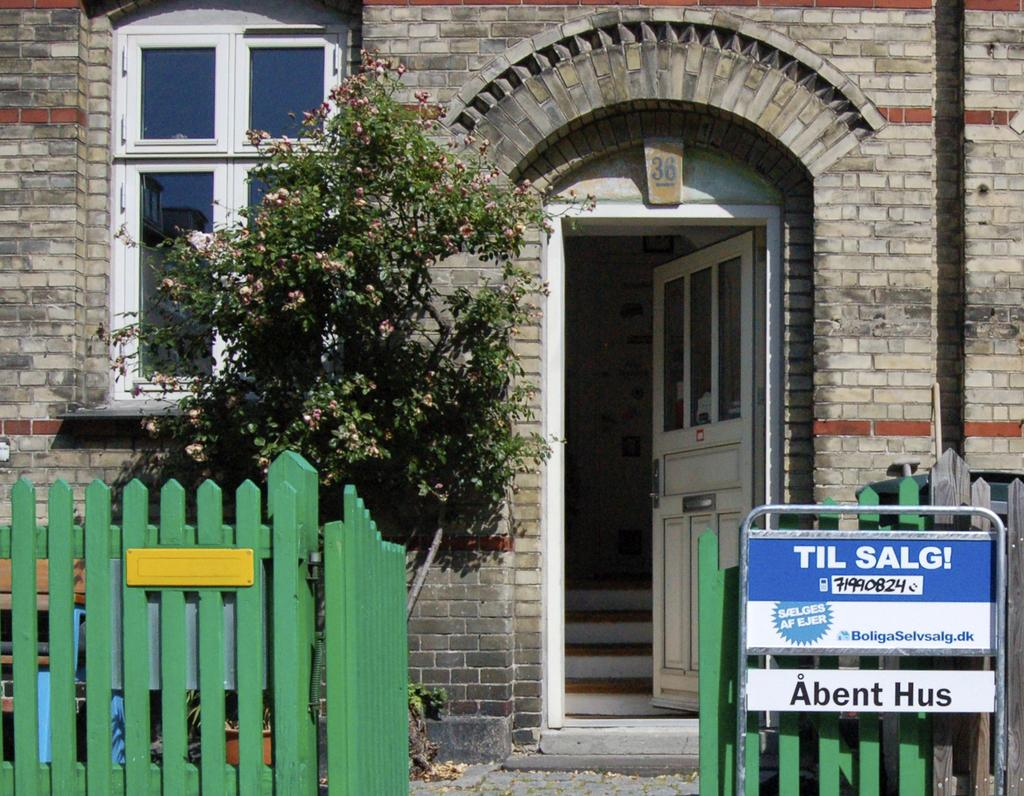What architectural feature can be seen in the image? There is a door, a window, and a wall in the image. What type of signage is present in the image? There are sign boards in the image. What type of barrier can be seen in the image? There is fencing in the image. What type of vegetation is present in the image? There is a plant in the image. What type of structure is present in the image? There are stairs in the image. What type of surface is present in the image? There is a floor in the image. What type of school can be seen in the image? There is no school present in the image. How many times can the plant be folded in the image? The plant cannot be folded, as it is a living organism and not a piece of paper or fabric. 